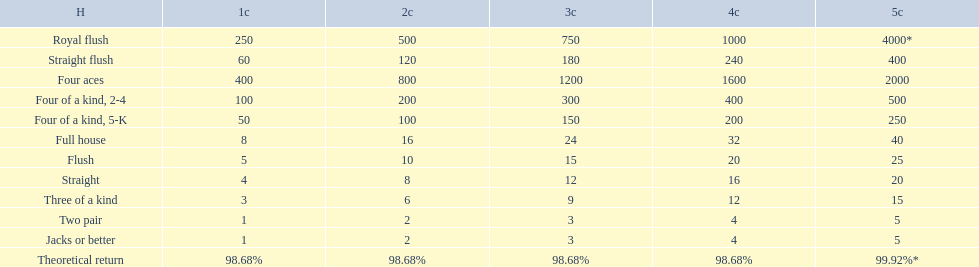What is the higher amount of points for one credit you can get from the best four of a kind 100. What type is it? Four of a kind, 2-4. 